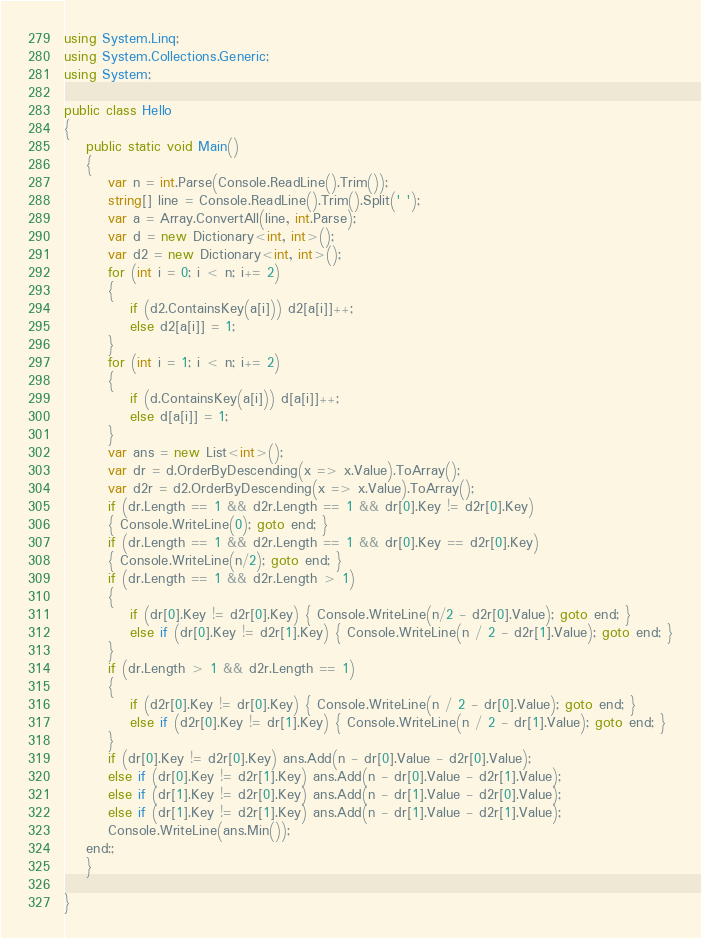<code> <loc_0><loc_0><loc_500><loc_500><_C#_>using System.Linq;
using System.Collections.Generic;
using System;

public class Hello
{
    public static void Main()
    {
        var n = int.Parse(Console.ReadLine().Trim());
        string[] line = Console.ReadLine().Trim().Split(' ');
        var a = Array.ConvertAll(line, int.Parse);
        var d = new Dictionary<int, int>();
        var d2 = new Dictionary<int, int>();
        for (int i = 0; i < n; i+= 2)
        {
            if (d2.ContainsKey(a[i])) d2[a[i]]++;
            else d2[a[i]] = 1;
        }
        for (int i = 1; i < n; i+= 2)
        {
            if (d.ContainsKey(a[i])) d[a[i]]++;
            else d[a[i]] = 1;
        }
        var ans = new List<int>();
        var dr = d.OrderByDescending(x => x.Value).ToArray();
        var d2r = d2.OrderByDescending(x => x.Value).ToArray();
        if (dr.Length == 1 && d2r.Length == 1 && dr[0].Key != d2r[0].Key)
        { Console.WriteLine(0); goto end; }
        if (dr.Length == 1 && d2r.Length == 1 && dr[0].Key == d2r[0].Key)
        { Console.WriteLine(n/2); goto end; }
        if (dr.Length == 1 && d2r.Length > 1)
        {
            if (dr[0].Key != d2r[0].Key) { Console.WriteLine(n/2 - d2r[0].Value); goto end; }
            else if (dr[0].Key != d2r[1].Key) { Console.WriteLine(n / 2 - d2r[1].Value); goto end; }
        }
        if (dr.Length > 1 && d2r.Length == 1)
        {
            if (d2r[0].Key != dr[0].Key) { Console.WriteLine(n / 2 - dr[0].Value); goto end; }
            else if (d2r[0].Key != dr[1].Key) { Console.WriteLine(n / 2 - dr[1].Value); goto end; }
        }
        if (dr[0].Key != d2r[0].Key) ans.Add(n - dr[0].Value - d2r[0].Value);
        else if (dr[0].Key != d2r[1].Key) ans.Add(n - dr[0].Value - d2r[1].Value);
        else if (dr[1].Key != d2r[0].Key) ans.Add(n - dr[1].Value - d2r[0].Value);
        else if (dr[1].Key != d2r[1].Key) ans.Add(n - dr[1].Value - d2r[1].Value);
        Console.WriteLine(ans.Min());
    end:;
    }

}
</code> 